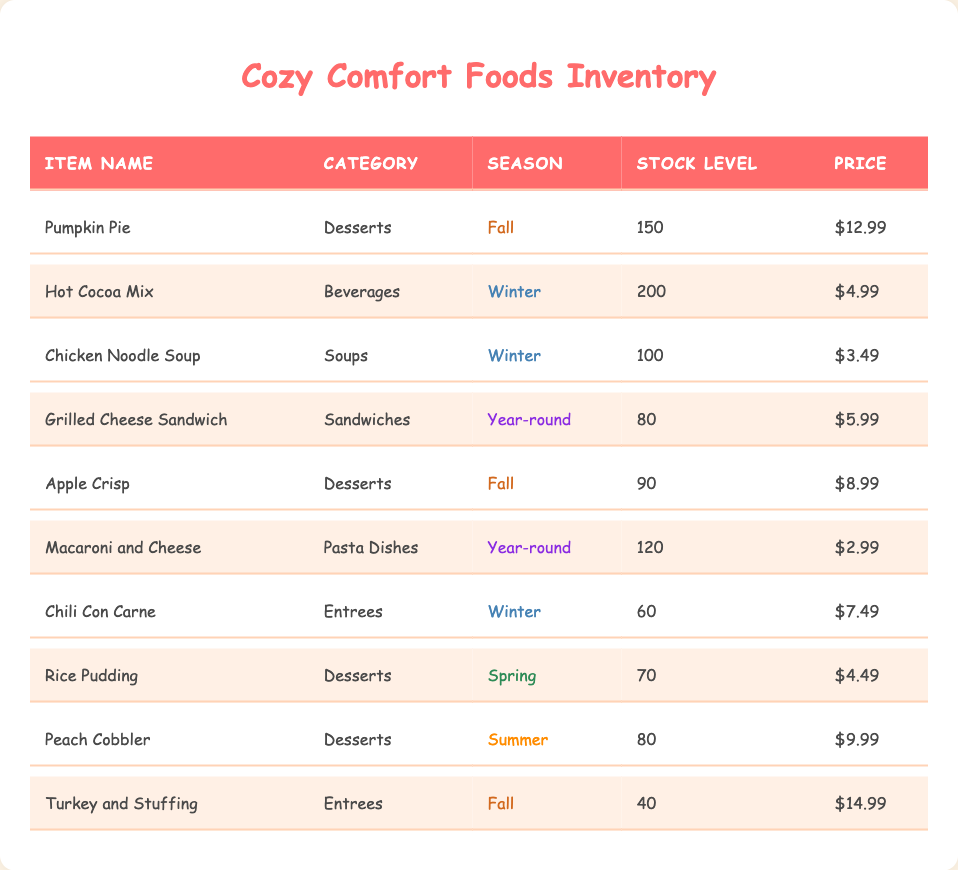What is the stock level of Pumpkin Pie? Pumpkin Pie is listed in the table under the comfort foods section with a stock level of 150. Therefore, the stock level for Pumpkin Pie is directly mentioned.
Answer: 150 Which food item has the highest price per unit? By reviewing the price per unit column, I see that Turkey and Stuffing is priced at $14.99 which is higher than all other items’ prices. Thus, it has the highest price.
Answer: Turkey and Stuffing Are there any desserts available in Winter? The table indicates both Hot Cocoa Mix and Chicken Noodle Soup as seasonal products of Winter, but none of the dessert items are listed for Winter. Thus, the answer is No.
Answer: No What is the total stock level of Fall season items? In the table, the items listed for Fall are Pumpkin Pie (150), Apple Crisp (90), and Turkey and Stuffing (40). Adding these gives us 150 + 90 + 40 = 280. Thus, the total stock for Fall items is 280.
Answer: 280 How many of the comfort foods are available year-round? The table lists Grilled Cheese Sandwich and Macaroni and Cheese as year-round comfort foods, so I count these two items. Therefore, there are 2 items available year-round.
Answer: 2 What is the average price of the desserts listed in the inventory? The desserts are Pumpkin Pie ($12.99), Apple Crisp ($8.99), Rice Pudding ($4.49), and Peach Cobbler ($9.99). Summing these gives $12.99 + $8.99 + $4.49 + $9.99 = $36.46. Dividing this by 4 (the number of dessert items) gives an average of $9.115, which can be rounded to $9.12.
Answer: 9.12 Is Chicken Noodle Soup included in multiple seasons? Chicken Noodle Soup is only listed for Winter and does not appear under any other seasons in the table. Hence, it is not included in multiple seasons. Therefore, the answer is No.
Answer: No Which food item has the lowest stock level? Looking at the stock levels in the table, Turkey and Stuffing has the lowest stock level at 40. Therefore, it is the food item with the least stock.
Answer: Turkey and Stuffing 